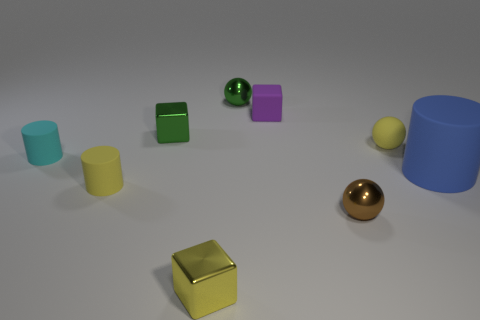Is there anything else that is the same size as the blue rubber cylinder?
Offer a very short reply. No. What material is the small green thing that is in front of the cube that is to the right of the metallic ball that is to the left of the purple matte thing?
Provide a short and direct response. Metal. There is a thing on the left side of the small yellow cylinder; how many blue rubber cylinders are behind it?
Your response must be concise. 0. There is a brown ball that is in front of the matte cube; is its size the same as the small yellow cube?
Your response must be concise. Yes. How many other shiny objects are the same shape as the big thing?
Ensure brevity in your answer.  0. What is the shape of the small brown shiny object?
Your response must be concise. Sphere. Are there an equal number of tiny yellow cylinders to the right of the large blue cylinder and large brown metallic objects?
Your answer should be very brief. Yes. Are the green object behind the small purple object and the small brown ball made of the same material?
Offer a terse response. Yes. Is the number of tiny purple things that are behind the green sphere less than the number of green rubber things?
Your answer should be very brief. No. What number of shiny objects are either big objects or small blocks?
Offer a very short reply. 2. 